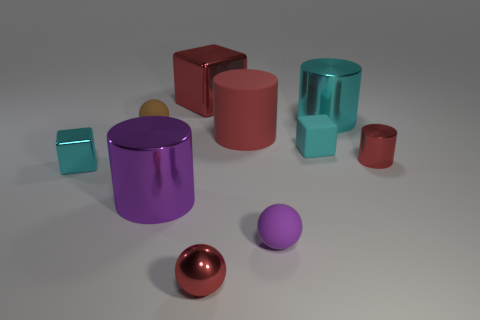Are there more tiny red objects that are on the left side of the red matte object than large cyan metal cylinders that are in front of the tiny cylinder?
Give a very brief answer. Yes. There is a tiny shiny object that is to the right of the small red shiny thing that is on the left side of the tiny rubber sphere that is in front of the big matte thing; what color is it?
Your answer should be very brief. Red. There is a sphere to the left of the big red metallic object; is its color the same as the rubber block?
Make the answer very short. No. What number of other objects are the same color as the big rubber cylinder?
Offer a terse response. 3. How many things are either tiny cyan matte blocks or big gray metal things?
Offer a terse response. 1. What number of things are either purple matte objects or metallic blocks behind the tiny cyan metal object?
Offer a very short reply. 2. Does the large cyan cylinder have the same material as the large purple thing?
Your response must be concise. Yes. How many other objects are the same material as the tiny cylinder?
Your response must be concise. 5. Are there more purple shiny objects than small cyan balls?
Provide a short and direct response. Yes. There is a red rubber object that is behind the cyan rubber object; is its shape the same as the purple metal object?
Give a very brief answer. Yes. 